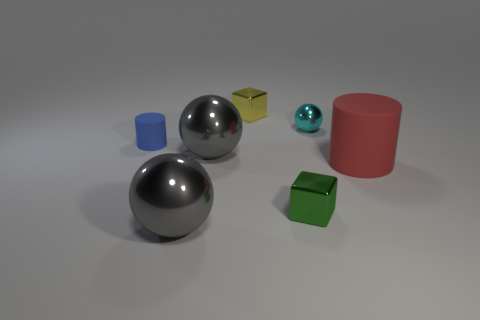Add 1 metallic things. How many objects exist? 8 Subtract all cylinders. How many objects are left? 5 Subtract all red matte objects. Subtract all gray balls. How many objects are left? 4 Add 5 small green objects. How many small green objects are left? 6 Add 6 tiny metal cubes. How many tiny metal cubes exist? 8 Subtract 0 purple cylinders. How many objects are left? 7 